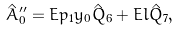Convert formula to latex. <formula><loc_0><loc_0><loc_500><loc_500>\hat { A } _ { 0 } ^ { \prime \prime } = E p _ { 1 } y _ { 0 } \hat { Q } _ { 6 } + E l \hat { Q } _ { 7 } ,</formula> 